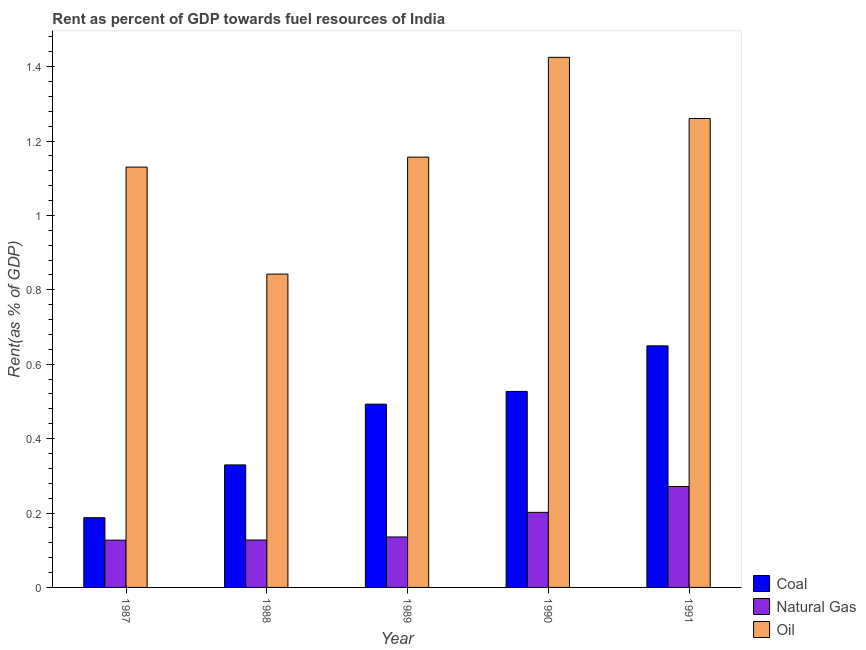How many different coloured bars are there?
Your response must be concise. 3. Are the number of bars per tick equal to the number of legend labels?
Offer a terse response. Yes. What is the rent towards coal in 1991?
Offer a very short reply. 0.65. Across all years, what is the maximum rent towards natural gas?
Provide a short and direct response. 0.27. Across all years, what is the minimum rent towards natural gas?
Give a very brief answer. 0.13. In which year was the rent towards natural gas minimum?
Your answer should be very brief. 1987. What is the total rent towards natural gas in the graph?
Offer a terse response. 0.86. What is the difference between the rent towards coal in 1988 and that in 1990?
Offer a terse response. -0.2. What is the difference between the rent towards natural gas in 1988 and the rent towards oil in 1987?
Ensure brevity in your answer.  0. What is the average rent towards coal per year?
Offer a terse response. 0.44. What is the ratio of the rent towards oil in 1987 to that in 1988?
Your response must be concise. 1.34. Is the rent towards natural gas in 1987 less than that in 1990?
Ensure brevity in your answer.  Yes. Is the difference between the rent towards oil in 1988 and 1991 greater than the difference between the rent towards coal in 1988 and 1991?
Provide a succinct answer. No. What is the difference between the highest and the second highest rent towards oil?
Make the answer very short. 0.16. What is the difference between the highest and the lowest rent towards coal?
Give a very brief answer. 0.46. What does the 1st bar from the left in 1989 represents?
Offer a very short reply. Coal. What does the 2nd bar from the right in 1988 represents?
Make the answer very short. Natural Gas. How many bars are there?
Provide a succinct answer. 15. Are all the bars in the graph horizontal?
Provide a succinct answer. No. How many years are there in the graph?
Make the answer very short. 5. Does the graph contain grids?
Ensure brevity in your answer.  No. How many legend labels are there?
Your response must be concise. 3. How are the legend labels stacked?
Offer a terse response. Vertical. What is the title of the graph?
Your response must be concise. Rent as percent of GDP towards fuel resources of India. What is the label or title of the Y-axis?
Ensure brevity in your answer.  Rent(as % of GDP). What is the Rent(as % of GDP) of Coal in 1987?
Your response must be concise. 0.19. What is the Rent(as % of GDP) in Natural Gas in 1987?
Keep it short and to the point. 0.13. What is the Rent(as % of GDP) in Oil in 1987?
Your answer should be very brief. 1.13. What is the Rent(as % of GDP) of Coal in 1988?
Your response must be concise. 0.33. What is the Rent(as % of GDP) in Natural Gas in 1988?
Give a very brief answer. 0.13. What is the Rent(as % of GDP) of Oil in 1988?
Your answer should be very brief. 0.84. What is the Rent(as % of GDP) in Coal in 1989?
Make the answer very short. 0.49. What is the Rent(as % of GDP) in Natural Gas in 1989?
Make the answer very short. 0.14. What is the Rent(as % of GDP) of Oil in 1989?
Your answer should be very brief. 1.16. What is the Rent(as % of GDP) of Coal in 1990?
Provide a succinct answer. 0.53. What is the Rent(as % of GDP) in Natural Gas in 1990?
Make the answer very short. 0.2. What is the Rent(as % of GDP) of Oil in 1990?
Keep it short and to the point. 1.42. What is the Rent(as % of GDP) in Coal in 1991?
Offer a very short reply. 0.65. What is the Rent(as % of GDP) of Natural Gas in 1991?
Provide a succinct answer. 0.27. What is the Rent(as % of GDP) in Oil in 1991?
Keep it short and to the point. 1.26. Across all years, what is the maximum Rent(as % of GDP) in Coal?
Provide a short and direct response. 0.65. Across all years, what is the maximum Rent(as % of GDP) of Natural Gas?
Provide a short and direct response. 0.27. Across all years, what is the maximum Rent(as % of GDP) in Oil?
Your answer should be very brief. 1.42. Across all years, what is the minimum Rent(as % of GDP) in Coal?
Give a very brief answer. 0.19. Across all years, what is the minimum Rent(as % of GDP) in Natural Gas?
Provide a short and direct response. 0.13. Across all years, what is the minimum Rent(as % of GDP) of Oil?
Your response must be concise. 0.84. What is the total Rent(as % of GDP) of Coal in the graph?
Ensure brevity in your answer.  2.19. What is the total Rent(as % of GDP) in Natural Gas in the graph?
Ensure brevity in your answer.  0.86. What is the total Rent(as % of GDP) of Oil in the graph?
Offer a terse response. 5.81. What is the difference between the Rent(as % of GDP) in Coal in 1987 and that in 1988?
Offer a very short reply. -0.14. What is the difference between the Rent(as % of GDP) of Natural Gas in 1987 and that in 1988?
Your answer should be compact. -0. What is the difference between the Rent(as % of GDP) of Oil in 1987 and that in 1988?
Offer a very short reply. 0.29. What is the difference between the Rent(as % of GDP) in Coal in 1987 and that in 1989?
Your answer should be compact. -0.31. What is the difference between the Rent(as % of GDP) of Natural Gas in 1987 and that in 1989?
Give a very brief answer. -0.01. What is the difference between the Rent(as % of GDP) of Oil in 1987 and that in 1989?
Offer a terse response. -0.03. What is the difference between the Rent(as % of GDP) in Coal in 1987 and that in 1990?
Your answer should be very brief. -0.34. What is the difference between the Rent(as % of GDP) in Natural Gas in 1987 and that in 1990?
Give a very brief answer. -0.07. What is the difference between the Rent(as % of GDP) of Oil in 1987 and that in 1990?
Provide a short and direct response. -0.3. What is the difference between the Rent(as % of GDP) in Coal in 1987 and that in 1991?
Provide a short and direct response. -0.46. What is the difference between the Rent(as % of GDP) in Natural Gas in 1987 and that in 1991?
Your answer should be compact. -0.14. What is the difference between the Rent(as % of GDP) in Oil in 1987 and that in 1991?
Give a very brief answer. -0.13. What is the difference between the Rent(as % of GDP) of Coal in 1988 and that in 1989?
Your response must be concise. -0.16. What is the difference between the Rent(as % of GDP) in Natural Gas in 1988 and that in 1989?
Your answer should be very brief. -0.01. What is the difference between the Rent(as % of GDP) of Oil in 1988 and that in 1989?
Make the answer very short. -0.31. What is the difference between the Rent(as % of GDP) in Coal in 1988 and that in 1990?
Offer a terse response. -0.2. What is the difference between the Rent(as % of GDP) in Natural Gas in 1988 and that in 1990?
Ensure brevity in your answer.  -0.07. What is the difference between the Rent(as % of GDP) of Oil in 1988 and that in 1990?
Your answer should be very brief. -0.58. What is the difference between the Rent(as % of GDP) of Coal in 1988 and that in 1991?
Provide a succinct answer. -0.32. What is the difference between the Rent(as % of GDP) in Natural Gas in 1988 and that in 1991?
Provide a short and direct response. -0.14. What is the difference between the Rent(as % of GDP) in Oil in 1988 and that in 1991?
Keep it short and to the point. -0.42. What is the difference between the Rent(as % of GDP) of Coal in 1989 and that in 1990?
Keep it short and to the point. -0.03. What is the difference between the Rent(as % of GDP) of Natural Gas in 1989 and that in 1990?
Offer a very short reply. -0.07. What is the difference between the Rent(as % of GDP) in Oil in 1989 and that in 1990?
Provide a succinct answer. -0.27. What is the difference between the Rent(as % of GDP) of Coal in 1989 and that in 1991?
Your answer should be very brief. -0.16. What is the difference between the Rent(as % of GDP) of Natural Gas in 1989 and that in 1991?
Provide a short and direct response. -0.14. What is the difference between the Rent(as % of GDP) in Oil in 1989 and that in 1991?
Keep it short and to the point. -0.1. What is the difference between the Rent(as % of GDP) of Coal in 1990 and that in 1991?
Provide a short and direct response. -0.12. What is the difference between the Rent(as % of GDP) in Natural Gas in 1990 and that in 1991?
Ensure brevity in your answer.  -0.07. What is the difference between the Rent(as % of GDP) in Oil in 1990 and that in 1991?
Your answer should be very brief. 0.16. What is the difference between the Rent(as % of GDP) of Coal in 1987 and the Rent(as % of GDP) of Natural Gas in 1988?
Your answer should be very brief. 0.06. What is the difference between the Rent(as % of GDP) of Coal in 1987 and the Rent(as % of GDP) of Oil in 1988?
Make the answer very short. -0.65. What is the difference between the Rent(as % of GDP) of Natural Gas in 1987 and the Rent(as % of GDP) of Oil in 1988?
Your answer should be very brief. -0.72. What is the difference between the Rent(as % of GDP) of Coal in 1987 and the Rent(as % of GDP) of Natural Gas in 1989?
Offer a very short reply. 0.05. What is the difference between the Rent(as % of GDP) in Coal in 1987 and the Rent(as % of GDP) in Oil in 1989?
Give a very brief answer. -0.97. What is the difference between the Rent(as % of GDP) of Natural Gas in 1987 and the Rent(as % of GDP) of Oil in 1989?
Make the answer very short. -1.03. What is the difference between the Rent(as % of GDP) in Coal in 1987 and the Rent(as % of GDP) in Natural Gas in 1990?
Make the answer very short. -0.01. What is the difference between the Rent(as % of GDP) in Coal in 1987 and the Rent(as % of GDP) in Oil in 1990?
Your answer should be compact. -1.24. What is the difference between the Rent(as % of GDP) in Natural Gas in 1987 and the Rent(as % of GDP) in Oil in 1990?
Your response must be concise. -1.3. What is the difference between the Rent(as % of GDP) in Coal in 1987 and the Rent(as % of GDP) in Natural Gas in 1991?
Keep it short and to the point. -0.08. What is the difference between the Rent(as % of GDP) of Coal in 1987 and the Rent(as % of GDP) of Oil in 1991?
Provide a short and direct response. -1.07. What is the difference between the Rent(as % of GDP) in Natural Gas in 1987 and the Rent(as % of GDP) in Oil in 1991?
Provide a succinct answer. -1.13. What is the difference between the Rent(as % of GDP) of Coal in 1988 and the Rent(as % of GDP) of Natural Gas in 1989?
Provide a short and direct response. 0.19. What is the difference between the Rent(as % of GDP) in Coal in 1988 and the Rent(as % of GDP) in Oil in 1989?
Your answer should be compact. -0.83. What is the difference between the Rent(as % of GDP) in Natural Gas in 1988 and the Rent(as % of GDP) in Oil in 1989?
Offer a terse response. -1.03. What is the difference between the Rent(as % of GDP) in Coal in 1988 and the Rent(as % of GDP) in Natural Gas in 1990?
Ensure brevity in your answer.  0.13. What is the difference between the Rent(as % of GDP) of Coal in 1988 and the Rent(as % of GDP) of Oil in 1990?
Make the answer very short. -1.1. What is the difference between the Rent(as % of GDP) in Natural Gas in 1988 and the Rent(as % of GDP) in Oil in 1990?
Ensure brevity in your answer.  -1.3. What is the difference between the Rent(as % of GDP) in Coal in 1988 and the Rent(as % of GDP) in Natural Gas in 1991?
Give a very brief answer. 0.06. What is the difference between the Rent(as % of GDP) in Coal in 1988 and the Rent(as % of GDP) in Oil in 1991?
Your answer should be compact. -0.93. What is the difference between the Rent(as % of GDP) in Natural Gas in 1988 and the Rent(as % of GDP) in Oil in 1991?
Your answer should be very brief. -1.13. What is the difference between the Rent(as % of GDP) of Coal in 1989 and the Rent(as % of GDP) of Natural Gas in 1990?
Give a very brief answer. 0.29. What is the difference between the Rent(as % of GDP) of Coal in 1989 and the Rent(as % of GDP) of Oil in 1990?
Give a very brief answer. -0.93. What is the difference between the Rent(as % of GDP) of Natural Gas in 1989 and the Rent(as % of GDP) of Oil in 1990?
Your response must be concise. -1.29. What is the difference between the Rent(as % of GDP) of Coal in 1989 and the Rent(as % of GDP) of Natural Gas in 1991?
Make the answer very short. 0.22. What is the difference between the Rent(as % of GDP) of Coal in 1989 and the Rent(as % of GDP) of Oil in 1991?
Offer a terse response. -0.77. What is the difference between the Rent(as % of GDP) of Natural Gas in 1989 and the Rent(as % of GDP) of Oil in 1991?
Keep it short and to the point. -1.12. What is the difference between the Rent(as % of GDP) in Coal in 1990 and the Rent(as % of GDP) in Natural Gas in 1991?
Your response must be concise. 0.26. What is the difference between the Rent(as % of GDP) in Coal in 1990 and the Rent(as % of GDP) in Oil in 1991?
Your answer should be compact. -0.73. What is the difference between the Rent(as % of GDP) in Natural Gas in 1990 and the Rent(as % of GDP) in Oil in 1991?
Keep it short and to the point. -1.06. What is the average Rent(as % of GDP) of Coal per year?
Your answer should be very brief. 0.44. What is the average Rent(as % of GDP) in Natural Gas per year?
Ensure brevity in your answer.  0.17. What is the average Rent(as % of GDP) of Oil per year?
Give a very brief answer. 1.16. In the year 1987, what is the difference between the Rent(as % of GDP) of Coal and Rent(as % of GDP) of Natural Gas?
Your answer should be compact. 0.06. In the year 1987, what is the difference between the Rent(as % of GDP) in Coal and Rent(as % of GDP) in Oil?
Offer a terse response. -0.94. In the year 1987, what is the difference between the Rent(as % of GDP) in Natural Gas and Rent(as % of GDP) in Oil?
Offer a terse response. -1. In the year 1988, what is the difference between the Rent(as % of GDP) of Coal and Rent(as % of GDP) of Natural Gas?
Offer a terse response. 0.2. In the year 1988, what is the difference between the Rent(as % of GDP) in Coal and Rent(as % of GDP) in Oil?
Make the answer very short. -0.51. In the year 1988, what is the difference between the Rent(as % of GDP) in Natural Gas and Rent(as % of GDP) in Oil?
Your response must be concise. -0.71. In the year 1989, what is the difference between the Rent(as % of GDP) in Coal and Rent(as % of GDP) in Natural Gas?
Your response must be concise. 0.36. In the year 1989, what is the difference between the Rent(as % of GDP) in Coal and Rent(as % of GDP) in Oil?
Offer a very short reply. -0.66. In the year 1989, what is the difference between the Rent(as % of GDP) of Natural Gas and Rent(as % of GDP) of Oil?
Offer a terse response. -1.02. In the year 1990, what is the difference between the Rent(as % of GDP) of Coal and Rent(as % of GDP) of Natural Gas?
Offer a terse response. 0.33. In the year 1990, what is the difference between the Rent(as % of GDP) of Coal and Rent(as % of GDP) of Oil?
Make the answer very short. -0.9. In the year 1990, what is the difference between the Rent(as % of GDP) of Natural Gas and Rent(as % of GDP) of Oil?
Offer a very short reply. -1.22. In the year 1991, what is the difference between the Rent(as % of GDP) of Coal and Rent(as % of GDP) of Natural Gas?
Your answer should be very brief. 0.38. In the year 1991, what is the difference between the Rent(as % of GDP) in Coal and Rent(as % of GDP) in Oil?
Keep it short and to the point. -0.61. In the year 1991, what is the difference between the Rent(as % of GDP) in Natural Gas and Rent(as % of GDP) in Oil?
Offer a very short reply. -0.99. What is the ratio of the Rent(as % of GDP) in Coal in 1987 to that in 1988?
Your answer should be very brief. 0.57. What is the ratio of the Rent(as % of GDP) in Natural Gas in 1987 to that in 1988?
Provide a succinct answer. 1. What is the ratio of the Rent(as % of GDP) in Oil in 1987 to that in 1988?
Make the answer very short. 1.34. What is the ratio of the Rent(as % of GDP) in Coal in 1987 to that in 1989?
Your response must be concise. 0.38. What is the ratio of the Rent(as % of GDP) in Natural Gas in 1987 to that in 1989?
Your answer should be very brief. 0.94. What is the ratio of the Rent(as % of GDP) in Oil in 1987 to that in 1989?
Your answer should be very brief. 0.98. What is the ratio of the Rent(as % of GDP) in Coal in 1987 to that in 1990?
Offer a terse response. 0.36. What is the ratio of the Rent(as % of GDP) of Natural Gas in 1987 to that in 1990?
Your answer should be compact. 0.63. What is the ratio of the Rent(as % of GDP) in Oil in 1987 to that in 1990?
Provide a succinct answer. 0.79. What is the ratio of the Rent(as % of GDP) in Coal in 1987 to that in 1991?
Provide a short and direct response. 0.29. What is the ratio of the Rent(as % of GDP) in Natural Gas in 1987 to that in 1991?
Your answer should be very brief. 0.47. What is the ratio of the Rent(as % of GDP) of Oil in 1987 to that in 1991?
Provide a short and direct response. 0.9. What is the ratio of the Rent(as % of GDP) of Coal in 1988 to that in 1989?
Ensure brevity in your answer.  0.67. What is the ratio of the Rent(as % of GDP) in Natural Gas in 1988 to that in 1989?
Offer a very short reply. 0.94. What is the ratio of the Rent(as % of GDP) in Oil in 1988 to that in 1989?
Ensure brevity in your answer.  0.73. What is the ratio of the Rent(as % of GDP) in Coal in 1988 to that in 1990?
Offer a terse response. 0.62. What is the ratio of the Rent(as % of GDP) in Natural Gas in 1988 to that in 1990?
Your answer should be compact. 0.63. What is the ratio of the Rent(as % of GDP) in Oil in 1988 to that in 1990?
Offer a terse response. 0.59. What is the ratio of the Rent(as % of GDP) in Coal in 1988 to that in 1991?
Offer a terse response. 0.51. What is the ratio of the Rent(as % of GDP) of Natural Gas in 1988 to that in 1991?
Keep it short and to the point. 0.47. What is the ratio of the Rent(as % of GDP) of Oil in 1988 to that in 1991?
Make the answer very short. 0.67. What is the ratio of the Rent(as % of GDP) in Coal in 1989 to that in 1990?
Give a very brief answer. 0.93. What is the ratio of the Rent(as % of GDP) of Natural Gas in 1989 to that in 1990?
Ensure brevity in your answer.  0.67. What is the ratio of the Rent(as % of GDP) in Oil in 1989 to that in 1990?
Offer a terse response. 0.81. What is the ratio of the Rent(as % of GDP) in Coal in 1989 to that in 1991?
Give a very brief answer. 0.76. What is the ratio of the Rent(as % of GDP) in Natural Gas in 1989 to that in 1991?
Offer a very short reply. 0.5. What is the ratio of the Rent(as % of GDP) of Oil in 1989 to that in 1991?
Your answer should be very brief. 0.92. What is the ratio of the Rent(as % of GDP) of Coal in 1990 to that in 1991?
Make the answer very short. 0.81. What is the ratio of the Rent(as % of GDP) in Natural Gas in 1990 to that in 1991?
Give a very brief answer. 0.74. What is the ratio of the Rent(as % of GDP) in Oil in 1990 to that in 1991?
Provide a succinct answer. 1.13. What is the difference between the highest and the second highest Rent(as % of GDP) in Coal?
Your answer should be very brief. 0.12. What is the difference between the highest and the second highest Rent(as % of GDP) of Natural Gas?
Offer a terse response. 0.07. What is the difference between the highest and the second highest Rent(as % of GDP) in Oil?
Ensure brevity in your answer.  0.16. What is the difference between the highest and the lowest Rent(as % of GDP) in Coal?
Ensure brevity in your answer.  0.46. What is the difference between the highest and the lowest Rent(as % of GDP) of Natural Gas?
Make the answer very short. 0.14. What is the difference between the highest and the lowest Rent(as % of GDP) of Oil?
Your answer should be very brief. 0.58. 